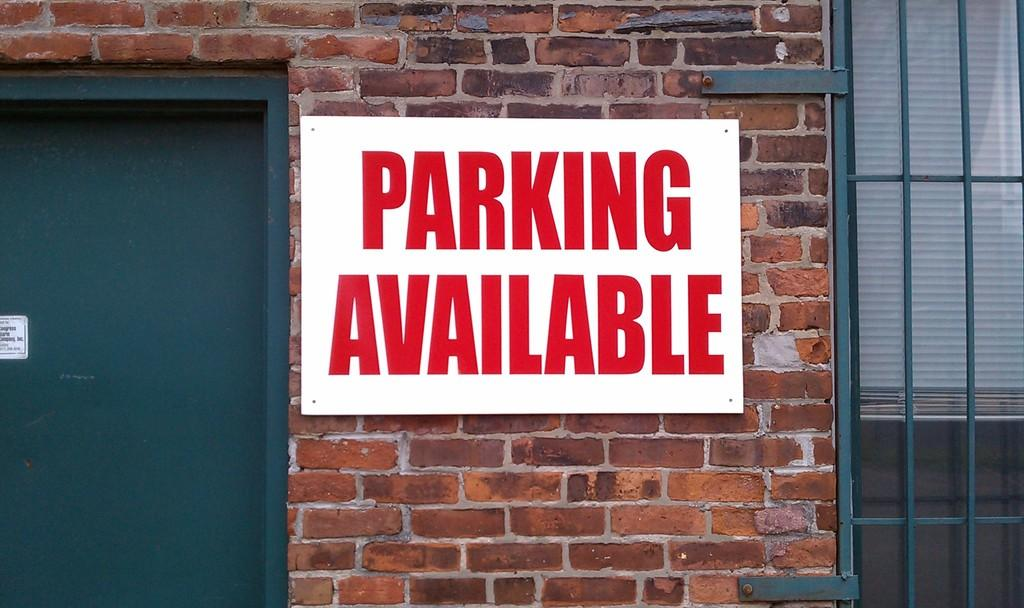What is placed on the brick wall in the image? There is a board placed on a brick wall in the image. What can be seen on the board? There is writing on the board. What architectural feature is on the right side of the image? There is a window on the right side of the image. What architectural feature is on the left side of the image? There is a door on the left side of the image. What type of society is depicted in the story on the board? There is no story or society mentioned in the image; it only features a board with writing on it, a brick wall, a window, and a door. 